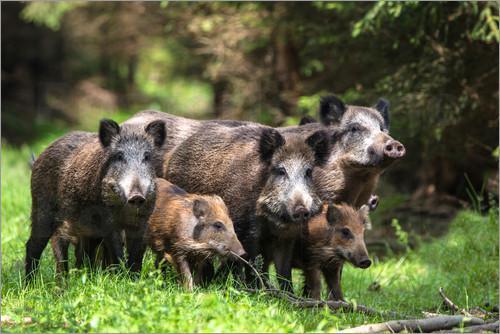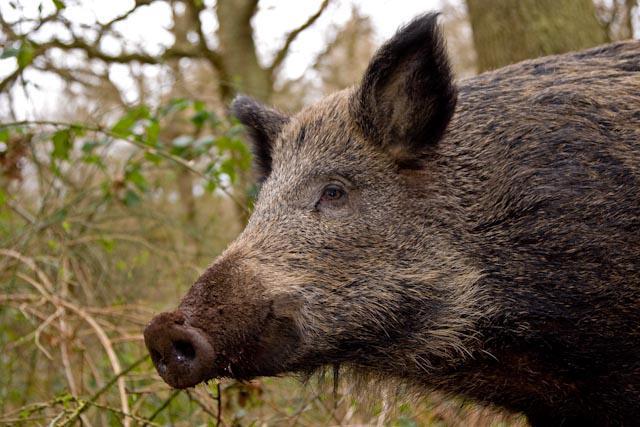The first image is the image on the left, the second image is the image on the right. Given the left and right images, does the statement "There are two hogs in total." hold true? Answer yes or no. No. The first image is the image on the left, the second image is the image on the right. For the images displayed, is the sentence "One image shows a single adult pig in profile, and the other image includes at least one adult wild pig with two smaller piglets." factually correct? Answer yes or no. Yes. 